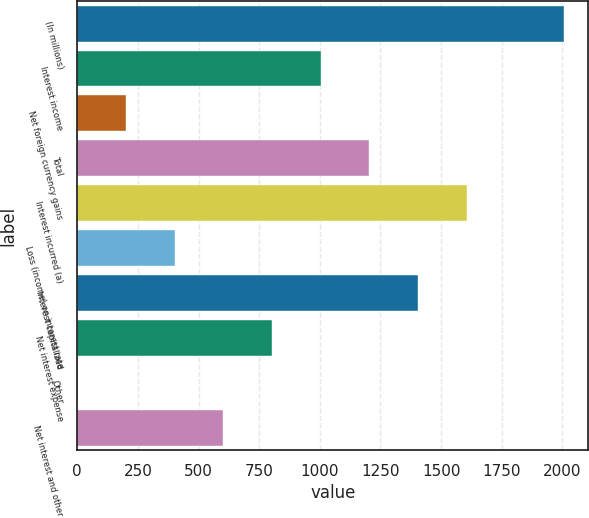<chart> <loc_0><loc_0><loc_500><loc_500><bar_chart><fcel>(In millions)<fcel>Interest income<fcel>Net foreign currency gains<fcel>Total<fcel>Interest incurred (a)<fcel>Loss (income) on interest rate<fcel>Interest capitalized<fcel>Net interest expense<fcel>Other<fcel>Net interest and other<nl><fcel>2006<fcel>1003.5<fcel>201.5<fcel>1204<fcel>1605<fcel>402<fcel>1404.5<fcel>803<fcel>1<fcel>602.5<nl></chart> 